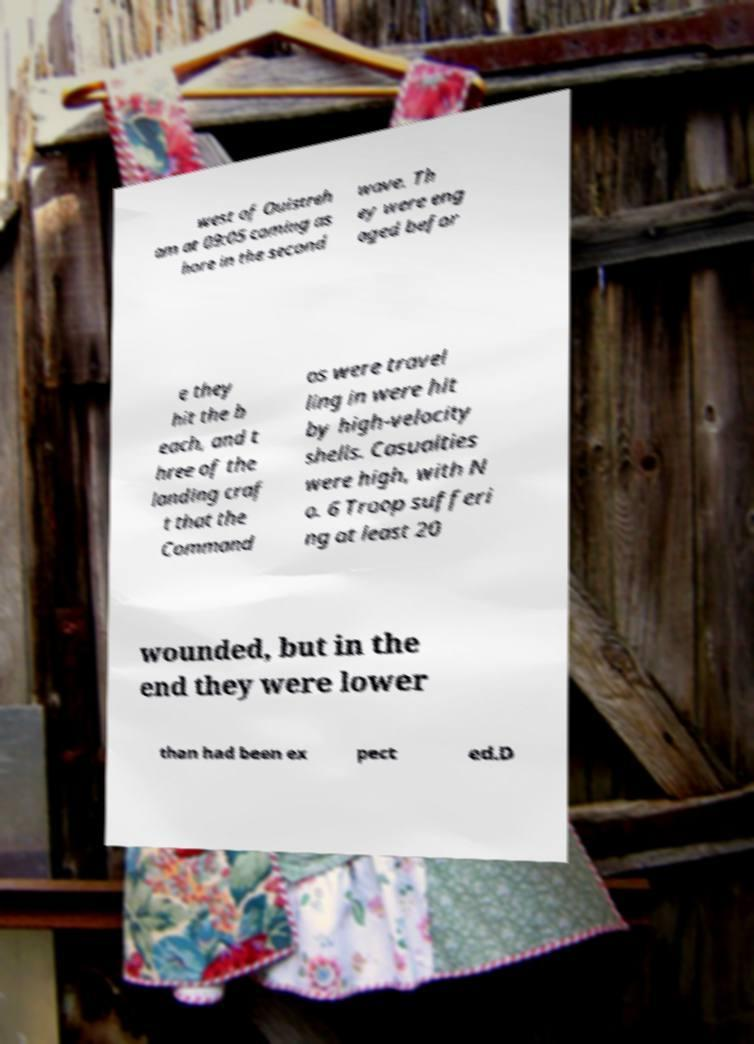Could you assist in decoding the text presented in this image and type it out clearly? west of Ouistreh am at 09:05 coming as hore in the second wave. Th ey were eng aged befor e they hit the b each, and t hree of the landing craf t that the Command os were travel ling in were hit by high-velocity shells. Casualties were high, with N o. 6 Troop sufferi ng at least 20 wounded, but in the end they were lower than had been ex pect ed.D 